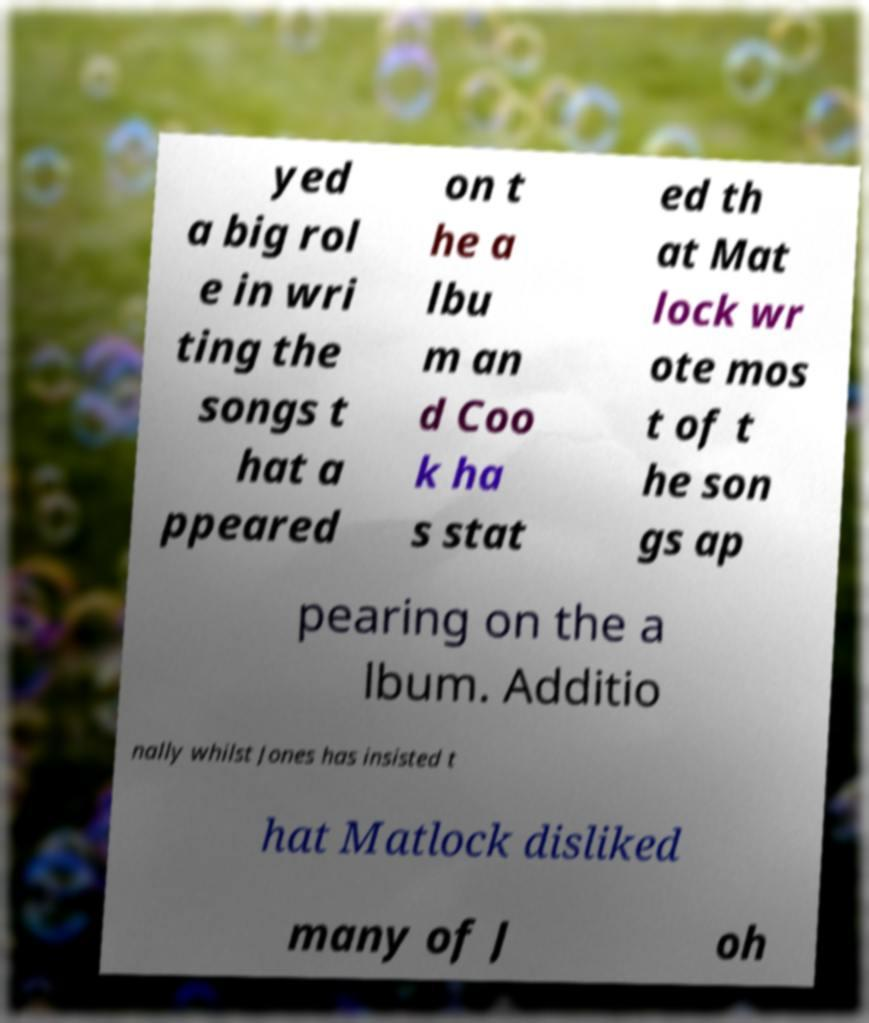Please read and relay the text visible in this image. What does it say? yed a big rol e in wri ting the songs t hat a ppeared on t he a lbu m an d Coo k ha s stat ed th at Mat lock wr ote mos t of t he son gs ap pearing on the a lbum. Additio nally whilst Jones has insisted t hat Matlock disliked many of J oh 